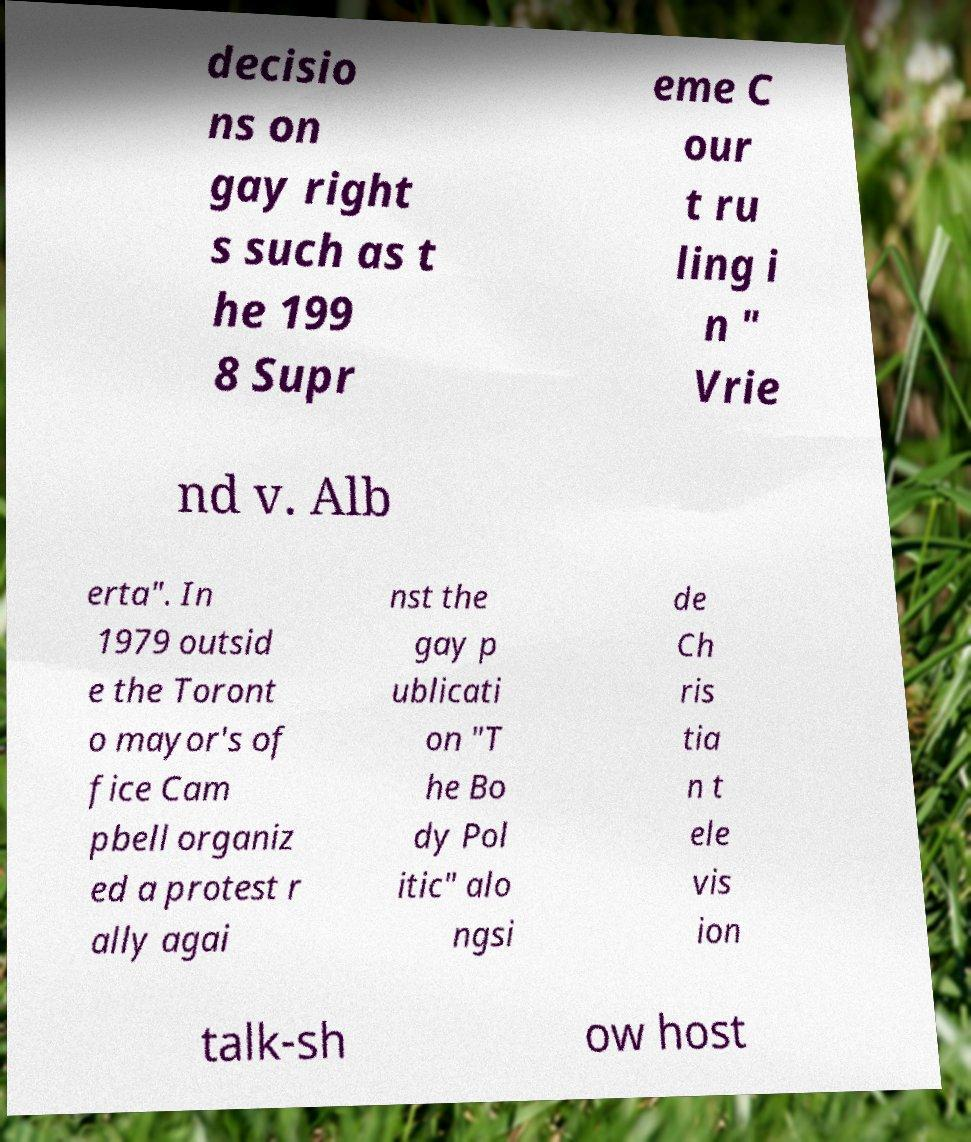Can you accurately transcribe the text from the provided image for me? decisio ns on gay right s such as t he 199 8 Supr eme C our t ru ling i n " Vrie nd v. Alb erta". In 1979 outsid e the Toront o mayor's of fice Cam pbell organiz ed a protest r ally agai nst the gay p ublicati on "T he Bo dy Pol itic" alo ngsi de Ch ris tia n t ele vis ion talk-sh ow host 